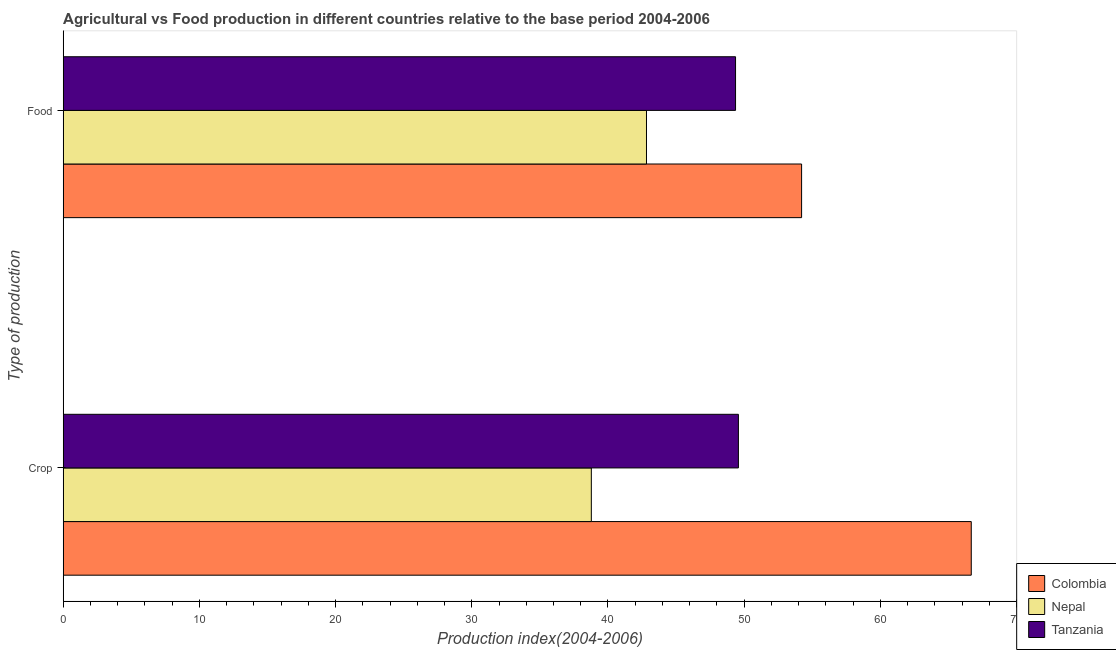How many different coloured bars are there?
Your answer should be very brief. 3. How many groups of bars are there?
Your answer should be compact. 2. Are the number of bars on each tick of the Y-axis equal?
Provide a short and direct response. Yes. How many bars are there on the 2nd tick from the bottom?
Provide a short and direct response. 3. What is the label of the 1st group of bars from the top?
Provide a short and direct response. Food. What is the food production index in Nepal?
Give a very brief answer. 42.83. Across all countries, what is the maximum crop production index?
Give a very brief answer. 66.68. Across all countries, what is the minimum crop production index?
Provide a succinct answer. 38.78. In which country was the food production index maximum?
Your response must be concise. Colombia. In which country was the food production index minimum?
Your response must be concise. Nepal. What is the total food production index in the graph?
Your answer should be compact. 146.42. What is the difference between the crop production index in Tanzania and that in Colombia?
Provide a succinct answer. -17.1. What is the difference between the crop production index in Colombia and the food production index in Tanzania?
Make the answer very short. 17.31. What is the average crop production index per country?
Make the answer very short. 51.68. What is the difference between the food production index and crop production index in Nepal?
Offer a terse response. 4.05. What is the ratio of the food production index in Nepal to that in Colombia?
Your answer should be compact. 0.79. Is the food production index in Nepal less than that in Colombia?
Your answer should be compact. Yes. In how many countries, is the crop production index greater than the average crop production index taken over all countries?
Ensure brevity in your answer.  1. What does the 1st bar from the top in Crop represents?
Your answer should be very brief. Tanzania. What does the 3rd bar from the bottom in Food represents?
Make the answer very short. Tanzania. How many bars are there?
Your answer should be very brief. 6. How many countries are there in the graph?
Your answer should be very brief. 3. Are the values on the major ticks of X-axis written in scientific E-notation?
Offer a terse response. No. Does the graph contain any zero values?
Make the answer very short. No. Does the graph contain grids?
Your answer should be very brief. No. How many legend labels are there?
Your answer should be compact. 3. How are the legend labels stacked?
Offer a very short reply. Vertical. What is the title of the graph?
Ensure brevity in your answer.  Agricultural vs Food production in different countries relative to the base period 2004-2006. Does "St. Martin (French part)" appear as one of the legend labels in the graph?
Offer a very short reply. No. What is the label or title of the X-axis?
Provide a short and direct response. Production index(2004-2006). What is the label or title of the Y-axis?
Your answer should be very brief. Type of production. What is the Production index(2004-2006) in Colombia in Crop?
Make the answer very short. 66.68. What is the Production index(2004-2006) in Nepal in Crop?
Your answer should be compact. 38.78. What is the Production index(2004-2006) of Tanzania in Crop?
Give a very brief answer. 49.58. What is the Production index(2004-2006) of Colombia in Food?
Offer a terse response. 54.22. What is the Production index(2004-2006) in Nepal in Food?
Keep it short and to the point. 42.83. What is the Production index(2004-2006) in Tanzania in Food?
Give a very brief answer. 49.37. Across all Type of production, what is the maximum Production index(2004-2006) in Colombia?
Make the answer very short. 66.68. Across all Type of production, what is the maximum Production index(2004-2006) of Nepal?
Keep it short and to the point. 42.83. Across all Type of production, what is the maximum Production index(2004-2006) of Tanzania?
Your answer should be compact. 49.58. Across all Type of production, what is the minimum Production index(2004-2006) of Colombia?
Your answer should be compact. 54.22. Across all Type of production, what is the minimum Production index(2004-2006) of Nepal?
Make the answer very short. 38.78. Across all Type of production, what is the minimum Production index(2004-2006) of Tanzania?
Give a very brief answer. 49.37. What is the total Production index(2004-2006) of Colombia in the graph?
Your answer should be compact. 120.9. What is the total Production index(2004-2006) in Nepal in the graph?
Provide a succinct answer. 81.61. What is the total Production index(2004-2006) of Tanzania in the graph?
Offer a very short reply. 98.95. What is the difference between the Production index(2004-2006) of Colombia in Crop and that in Food?
Provide a short and direct response. 12.46. What is the difference between the Production index(2004-2006) in Nepal in Crop and that in Food?
Your answer should be very brief. -4.05. What is the difference between the Production index(2004-2006) in Tanzania in Crop and that in Food?
Offer a terse response. 0.21. What is the difference between the Production index(2004-2006) in Colombia in Crop and the Production index(2004-2006) in Nepal in Food?
Keep it short and to the point. 23.85. What is the difference between the Production index(2004-2006) of Colombia in Crop and the Production index(2004-2006) of Tanzania in Food?
Offer a very short reply. 17.31. What is the difference between the Production index(2004-2006) of Nepal in Crop and the Production index(2004-2006) of Tanzania in Food?
Your answer should be compact. -10.59. What is the average Production index(2004-2006) of Colombia per Type of production?
Offer a very short reply. 60.45. What is the average Production index(2004-2006) in Nepal per Type of production?
Your response must be concise. 40.8. What is the average Production index(2004-2006) in Tanzania per Type of production?
Ensure brevity in your answer.  49.48. What is the difference between the Production index(2004-2006) of Colombia and Production index(2004-2006) of Nepal in Crop?
Offer a terse response. 27.9. What is the difference between the Production index(2004-2006) in Colombia and Production index(2004-2006) in Tanzania in Crop?
Offer a terse response. 17.1. What is the difference between the Production index(2004-2006) of Colombia and Production index(2004-2006) of Nepal in Food?
Provide a succinct answer. 11.39. What is the difference between the Production index(2004-2006) of Colombia and Production index(2004-2006) of Tanzania in Food?
Your response must be concise. 4.85. What is the difference between the Production index(2004-2006) of Nepal and Production index(2004-2006) of Tanzania in Food?
Keep it short and to the point. -6.54. What is the ratio of the Production index(2004-2006) in Colombia in Crop to that in Food?
Keep it short and to the point. 1.23. What is the ratio of the Production index(2004-2006) in Nepal in Crop to that in Food?
Provide a succinct answer. 0.91. What is the difference between the highest and the second highest Production index(2004-2006) of Colombia?
Give a very brief answer. 12.46. What is the difference between the highest and the second highest Production index(2004-2006) in Nepal?
Keep it short and to the point. 4.05. What is the difference between the highest and the second highest Production index(2004-2006) in Tanzania?
Your response must be concise. 0.21. What is the difference between the highest and the lowest Production index(2004-2006) of Colombia?
Offer a very short reply. 12.46. What is the difference between the highest and the lowest Production index(2004-2006) of Nepal?
Ensure brevity in your answer.  4.05. What is the difference between the highest and the lowest Production index(2004-2006) in Tanzania?
Provide a succinct answer. 0.21. 